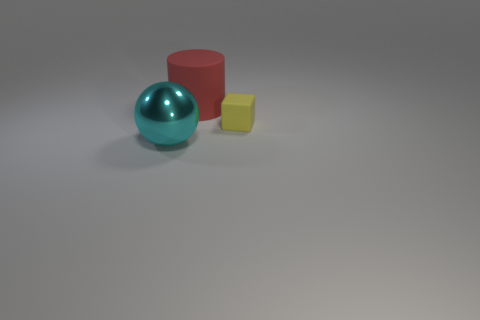There is a object that is both behind the large cyan thing and left of the tiny cube; what is its color?
Offer a terse response. Red. Is there a thing that is on the right side of the matte object on the right side of the rubber thing that is left of the small yellow object?
Provide a short and direct response. No. Are there any other things that have the same material as the big ball?
Provide a succinct answer. No. Is there a red cube?
Your response must be concise. No. What size is the rubber object that is to the right of the large object to the right of the thing in front of the matte block?
Provide a succinct answer. Small. How many other big metallic balls have the same color as the big ball?
Offer a terse response. 0. How many things are small brown things or objects that are right of the large red matte cylinder?
Give a very brief answer. 1. What color is the large matte cylinder?
Your answer should be compact. Red. What is the color of the object behind the small matte thing?
Offer a terse response. Red. There is a big object that is in front of the red thing; what number of tiny matte cubes are behind it?
Provide a short and direct response. 1. 